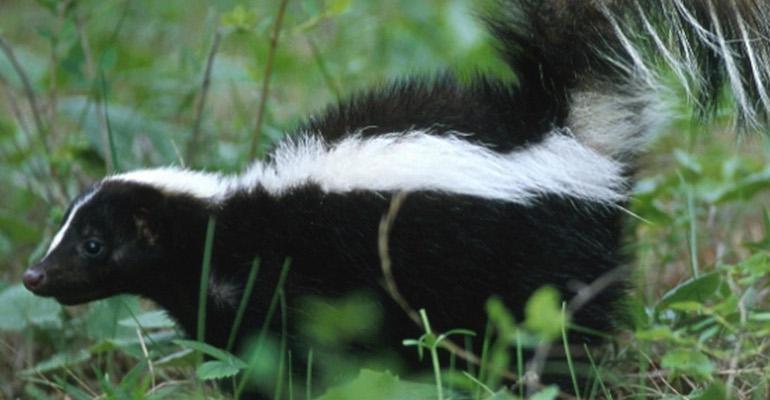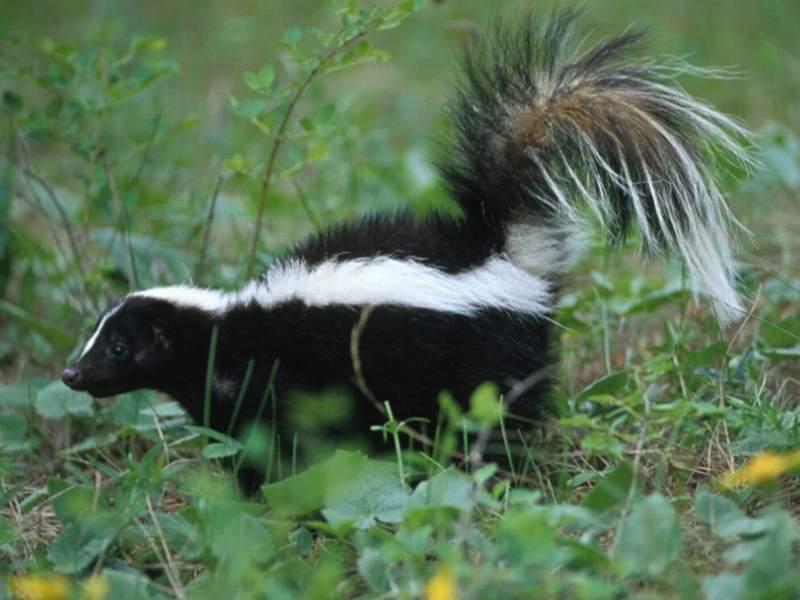The first image is the image on the left, the second image is the image on the right. Analyze the images presented: Is the assertion "In at least one image there is a single skunk facing left." valid? Answer yes or no. Yes. The first image is the image on the left, the second image is the image on the right. Examine the images to the left and right. Is the description "There is a single skunk in the right image." accurate? Answer yes or no. Yes. 